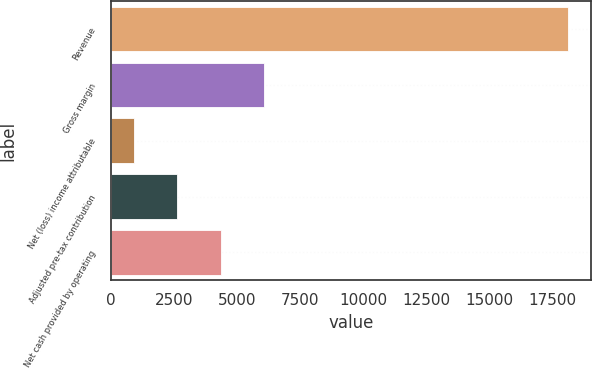Convert chart. <chart><loc_0><loc_0><loc_500><loc_500><bar_chart><fcel>Revenue<fcel>Gross margin<fcel>Net (loss) income attributable<fcel>Adjusted pre-tax contribution<fcel>Net cash provided by operating<nl><fcel>18141<fcel>6080.7<fcel>912<fcel>2634.9<fcel>4357.8<nl></chart> 